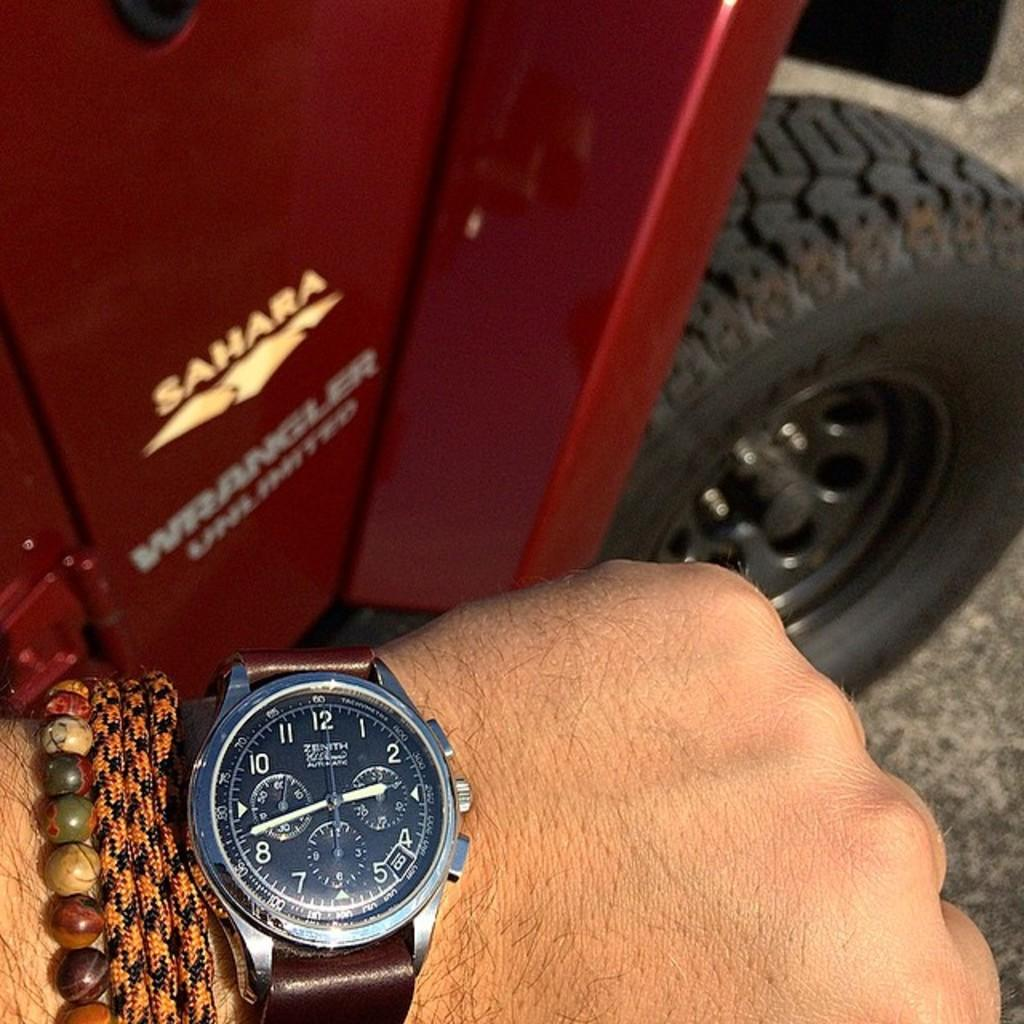<image>
Create a compact narrative representing the image presented. A man's watchin front of a Jeep Wrangler Sahara. 